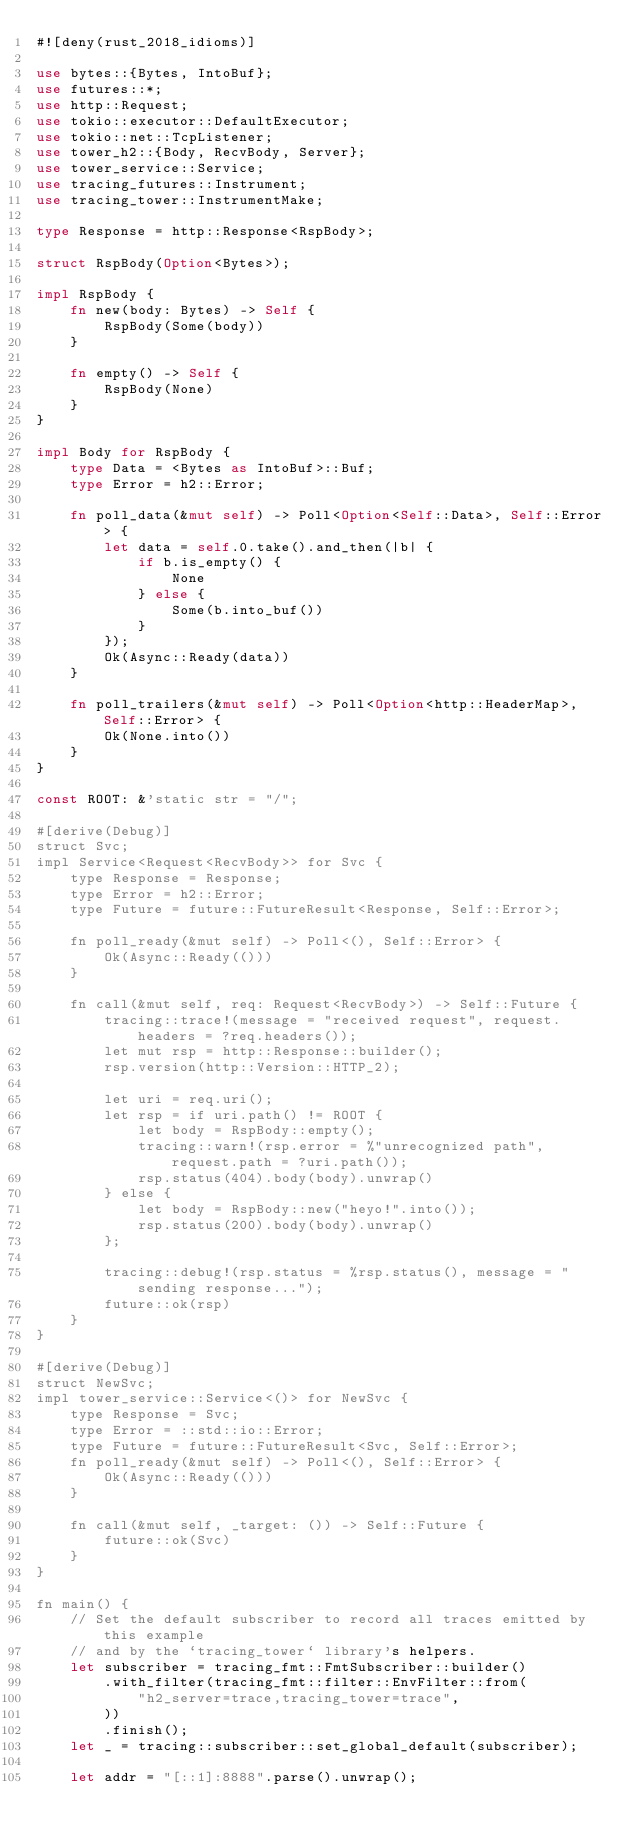<code> <loc_0><loc_0><loc_500><loc_500><_Rust_>#![deny(rust_2018_idioms)]

use bytes::{Bytes, IntoBuf};
use futures::*;
use http::Request;
use tokio::executor::DefaultExecutor;
use tokio::net::TcpListener;
use tower_h2::{Body, RecvBody, Server};
use tower_service::Service;
use tracing_futures::Instrument;
use tracing_tower::InstrumentMake;

type Response = http::Response<RspBody>;

struct RspBody(Option<Bytes>);

impl RspBody {
    fn new(body: Bytes) -> Self {
        RspBody(Some(body))
    }

    fn empty() -> Self {
        RspBody(None)
    }
}

impl Body for RspBody {
    type Data = <Bytes as IntoBuf>::Buf;
    type Error = h2::Error;

    fn poll_data(&mut self) -> Poll<Option<Self::Data>, Self::Error> {
        let data = self.0.take().and_then(|b| {
            if b.is_empty() {
                None
            } else {
                Some(b.into_buf())
            }
        });
        Ok(Async::Ready(data))
    }

    fn poll_trailers(&mut self) -> Poll<Option<http::HeaderMap>, Self::Error> {
        Ok(None.into())
    }
}

const ROOT: &'static str = "/";

#[derive(Debug)]
struct Svc;
impl Service<Request<RecvBody>> for Svc {
    type Response = Response;
    type Error = h2::Error;
    type Future = future::FutureResult<Response, Self::Error>;

    fn poll_ready(&mut self) -> Poll<(), Self::Error> {
        Ok(Async::Ready(()))
    }

    fn call(&mut self, req: Request<RecvBody>) -> Self::Future {
        tracing::trace!(message = "received request", request.headers = ?req.headers());
        let mut rsp = http::Response::builder();
        rsp.version(http::Version::HTTP_2);

        let uri = req.uri();
        let rsp = if uri.path() != ROOT {
            let body = RspBody::empty();
            tracing::warn!(rsp.error = %"unrecognized path", request.path = ?uri.path());
            rsp.status(404).body(body).unwrap()
        } else {
            let body = RspBody::new("heyo!".into());
            rsp.status(200).body(body).unwrap()
        };

        tracing::debug!(rsp.status = %rsp.status(), message = "sending response...");
        future::ok(rsp)
    }
}

#[derive(Debug)]
struct NewSvc;
impl tower_service::Service<()> for NewSvc {
    type Response = Svc;
    type Error = ::std::io::Error;
    type Future = future::FutureResult<Svc, Self::Error>;
    fn poll_ready(&mut self) -> Poll<(), Self::Error> {
        Ok(Async::Ready(()))
    }

    fn call(&mut self, _target: ()) -> Self::Future {
        future::ok(Svc)
    }
}

fn main() {
    // Set the default subscriber to record all traces emitted by this example
    // and by the `tracing_tower` library's helpers.
    let subscriber = tracing_fmt::FmtSubscriber::builder()
        .with_filter(tracing_fmt::filter::EnvFilter::from(
            "h2_server=trace,tracing_tower=trace",
        ))
        .finish();
    let _ = tracing::subscriber::set_global_default(subscriber);

    let addr = "[::1]:8888".parse().unwrap();</code> 